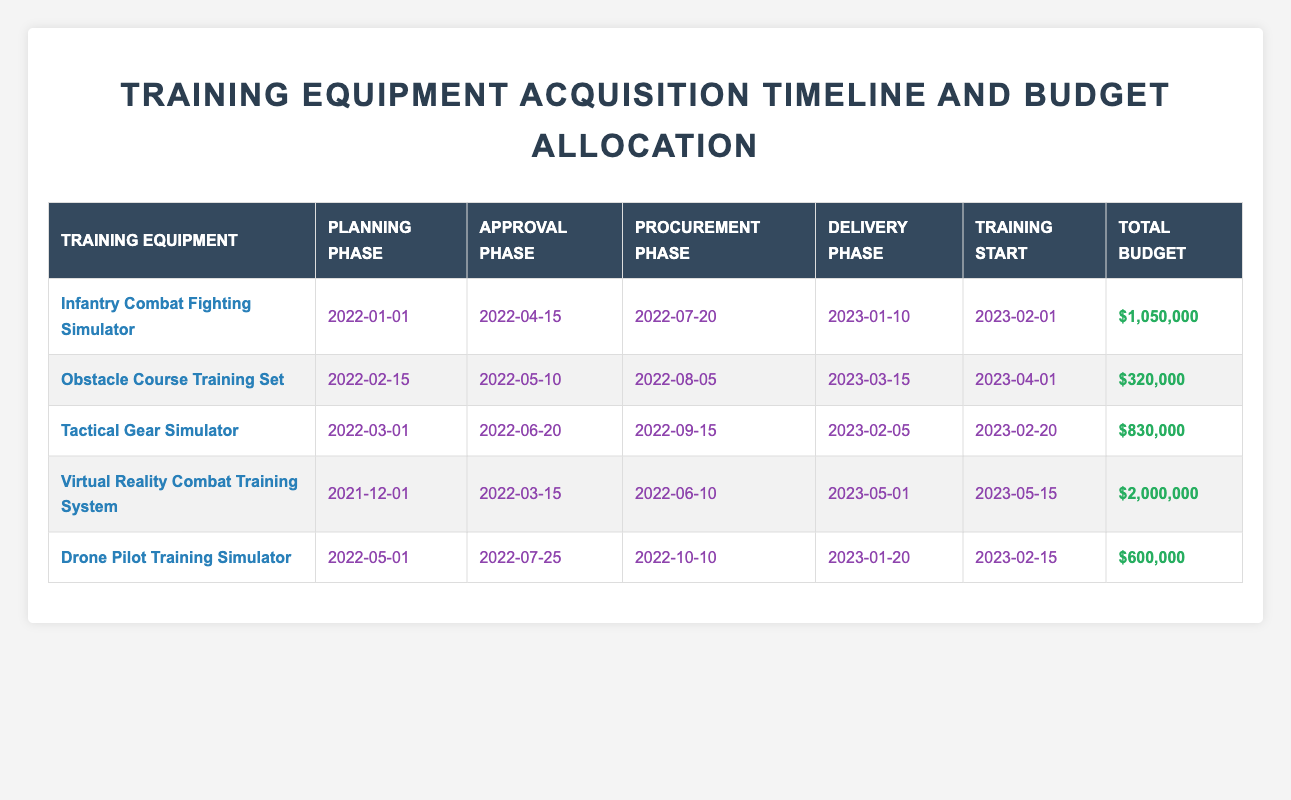What is the total budget allocated for the Tactical Gear Simulator? The total budget for the Tactical Gear Simulator is listed directly in the table under the "Total Budget" column, which shows "$830,000."
Answer: $830,000 When does the training start for the Drone Pilot Training Simulator? The "Training Start" date for the Drone Pilot Training Simulator is obtained from the respective column in the table, which indicates "2023-02-15."
Answer: 2023-02-15 Which training equipment has the longest acquisition timeline? To determine the longest acquisition timeline, one must compare the lengths of the timelines from planning to training start for each training equipment. The training equipment with the longest timeline is the Virtual Reality Combat Training System with a timeline from "2021-12-01" to "2023-05-15."
Answer: Virtual Reality Combat Training System What is the difference between the total budgets of the Infantry Combat Fighting Simulator and the Obstacle Course Training Set? The total budget for the Infantry Combat Fighting Simulator is "$1,050,000" and for the Obstacle Course Training Set, it is "$320,000." The difference is calculated as: $1,050,000 - $320,000 = $730,000.
Answer: $730,000 Is the procurement budget for the Virtual Reality Combat Training System higher than the combined procurement budgets of the other training equipment? The procurement budget for the Virtual Reality Combat Training System is "$1,200,000." The combined procurement budgets for the other training equipment are: $500,000 (Infantry Combat) + $200,000 (Obstacle Course) + $400,000 (Tactical Gear) + $300,000 (Drone Pilot) = $1,400,000. Since $1,200,000 is less, the answer is false.
Answer: No 